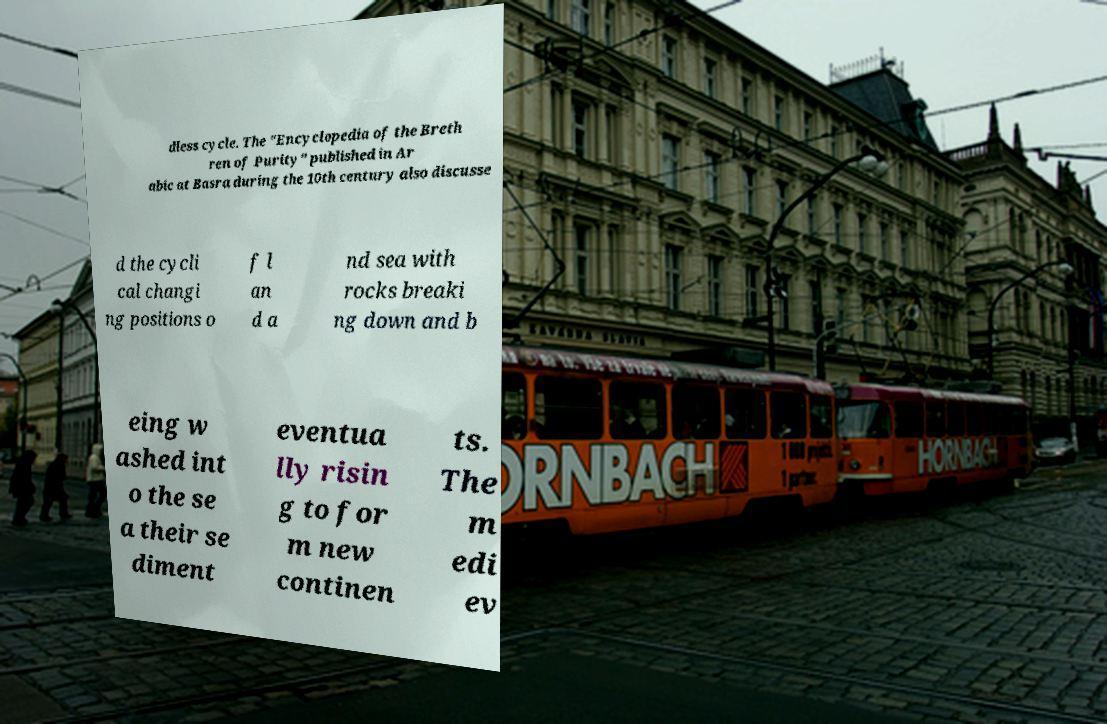I need the written content from this picture converted into text. Can you do that? dless cycle. The "Encyclopedia of the Breth ren of Purity" published in Ar abic at Basra during the 10th century also discusse d the cycli cal changi ng positions o f l an d a nd sea with rocks breaki ng down and b eing w ashed int o the se a their se diment eventua lly risin g to for m new continen ts. The m edi ev 